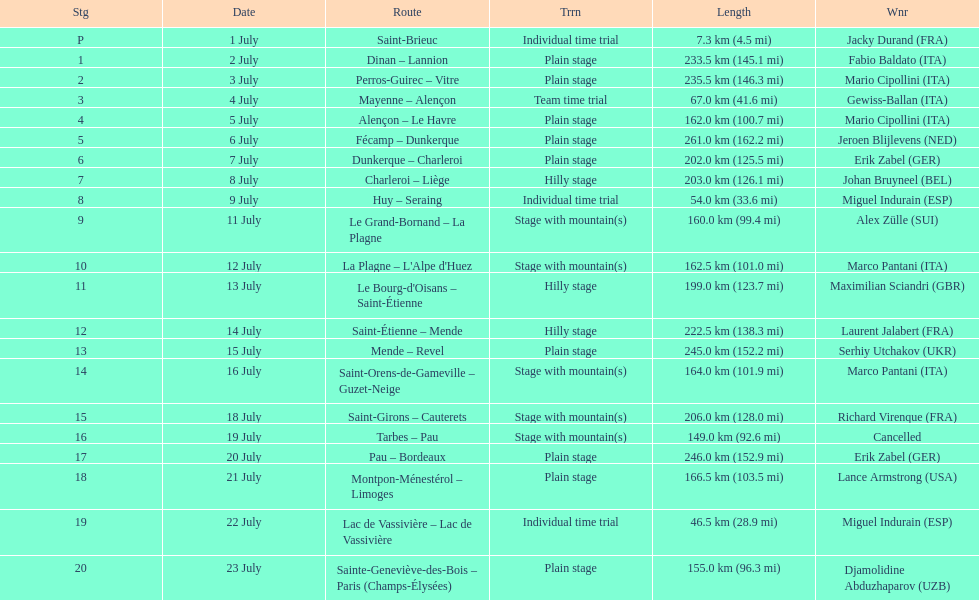How many stages were at least 200 km in length in the 1995 tour de france? 9. 